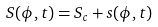<formula> <loc_0><loc_0><loc_500><loc_500>S ( \phi , t ) = S _ { c } + s ( \phi , t )</formula> 